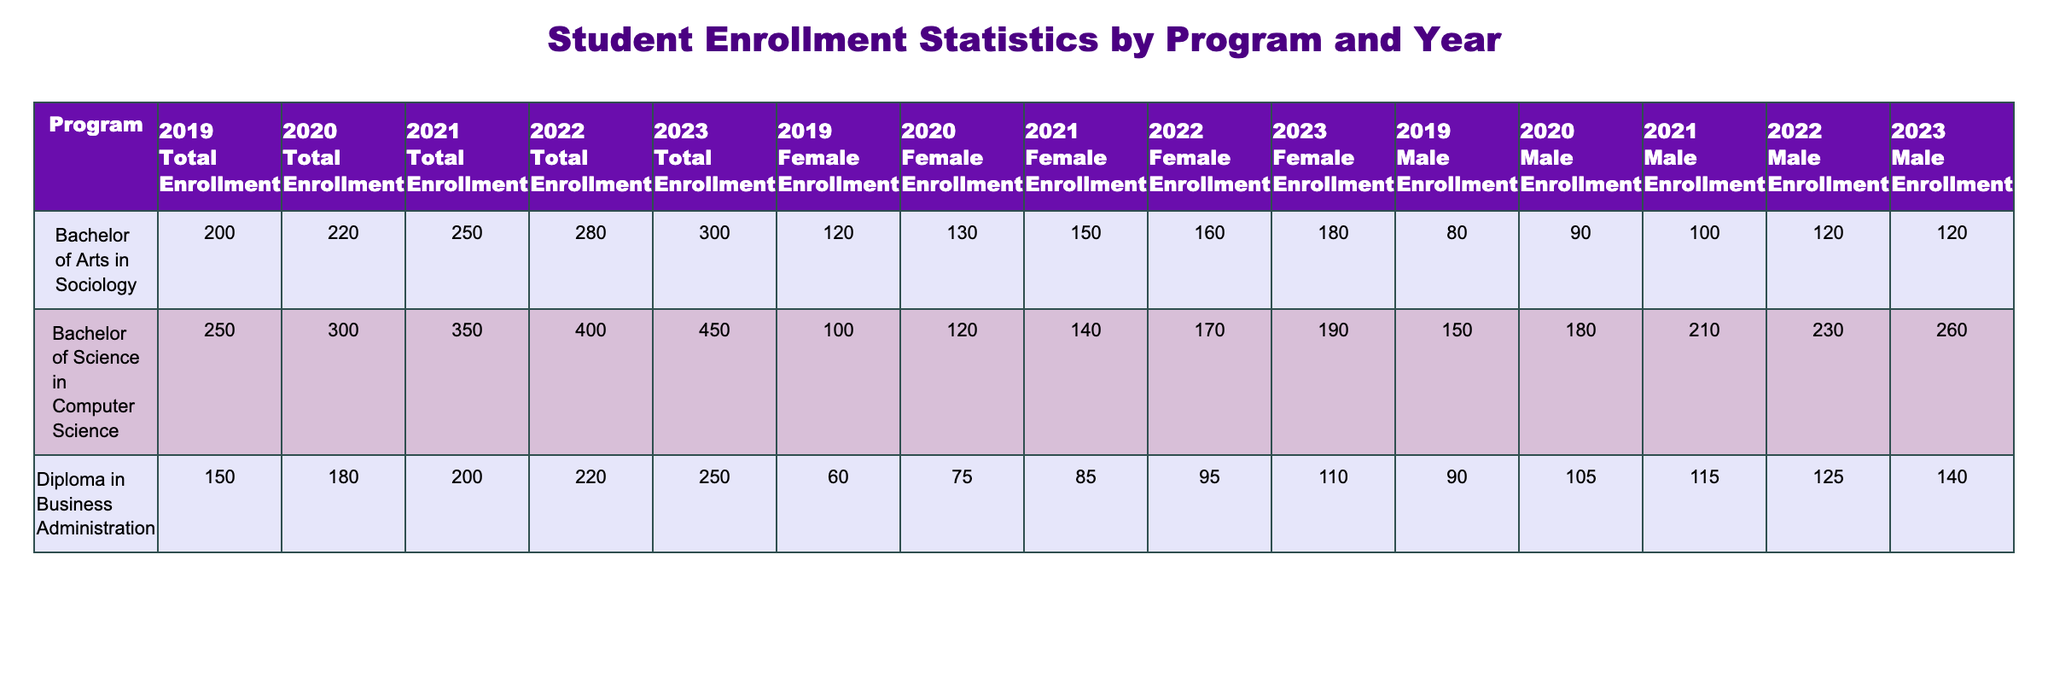What was the total enrollment for Diploma in Business Administration in 2021? In the table, locate the row for Diploma in Business Administration under the year 2021. The Total Enrollment value for this row is listed as 200.
Answer: 200 How many female students were enrolled in the Bachelor of Arts in Sociology in 2020? Look at the year 2020 and find the row for Bachelor of Arts in Sociology. The Female Enrollment for this program that year is 130.
Answer: 130 Which program had the highest total enrollment in 2023? To find the highest total enrollment in 2023, compare the Total Enrollment values across all programs for the year 2023: Bachelor of Science in Computer Science (450), Bachelor of Arts in Sociology (300), and Diploma in Business Administration (250). The Bachelor of Science in Computer Science has the highest enrollment at 450.
Answer: Bachelor of Science in Computer Science What is the difference in total enrollment between 2019 and 2022 for the Bachelor of Science in Computer Science? First, find the Total Enrollment for Bachelor of Science in Computer Science in both years: in 2019 it is 250, and in 2022 it is 400. Calculate the difference: 400 - 250 = 150.
Answer: 150 Is the male enrollment for Bachelor of Arts in Sociology higher than the female enrollment in 2021? In the 2021 row for Bachelor of Arts in Sociology, the Male Enrollment is 100 and the Female Enrollment is 150. Since 100 is not higher than 150, the answer is No.
Answer: No How has the female enrollment in the Bachelor of Science in Computer Science changed from 2019 to 2023? Look at the female enrollment values for Bachelor of Science in Computer Science: in 2019 it is 100, and in 2023 it is 190. The change is calculated as 190 - 100 = 90.
Answer: Increase of 90 What was the total enrollment across all programs in 2022? To find the total enrollment for 2022, sum the Total Enrollment values for all programs in that year: 400 (Computer Science) + 280 (Sociology) + 220 (Business Administration) = 900.
Answer: 900 In which year did Diploma in Business Administration have its highest male enrollment? Check the male enrollment values for Diploma in Business Administration from each year: 90 in 2019, 105 in 2020, 115 in 2021, 125 in 2022, and 140 in 2023. The highest value is 140 in 2023.
Answer: 2023 What is the average female enrollment for Bachelor of Arts in Sociology from 2019 to 2023? Find the female enrollment values for Bachelor of Arts in Sociology over those years: 120 (2019), 130 (2020), 150 (2021), 160 (2022), and 180 (2023). Sum these values: 120 + 130 + 150 + 160 + 180 = 840. Divide by the number of years, which is 5: 840 / 5 = 168.
Answer: 168 